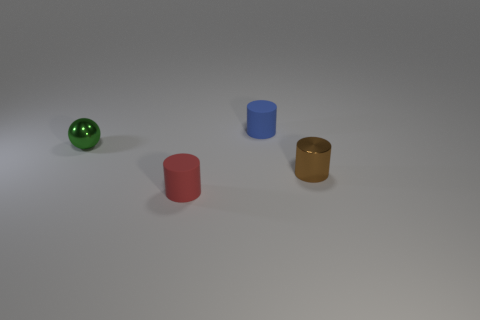Are there fewer shiny cylinders that are behind the tiny blue rubber object than tiny cylinders that are in front of the green sphere? Upon closer examination of the image, it appears that there are two cylinders positioned relative to the tiny blue rubber object and the green sphere. Directly behind the blue rubber object, there is one shiny golden cylinder. In front of the green sphere, also, there is only one cylinder, which is red. Therefore, the number of cylinders behind the blue object and in front of the green sphere is equal, not fewer, making it one each. 